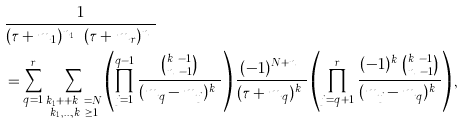<formula> <loc_0><loc_0><loc_500><loc_500>& \frac { 1 } { ( \tau + m _ { 1 } ) ^ { n _ { 1 } } \cdots ( \tau + m _ { r } ) ^ { n _ { r } } } \\ & = \sum _ { q = 1 } ^ { r } \sum _ { \substack { k _ { 1 } + \cdots + k _ { r } = N \\ k _ { 1 } , \dots , k _ { r } \geq 1 } } \left ( \prod _ { j = 1 } ^ { q - 1 } \frac { \binom { k _ { j } - 1 } { n _ { j } - 1 } } { ( m _ { q } - m _ { j } ) ^ { k _ { j } } } \right ) \frac { ( - 1 ) ^ { N + n _ { q } } } { ( \tau + m _ { q } ) ^ { k _ { q } } } \left ( \prod _ { j = q + 1 } ^ { r } \frac { ( - 1 ) ^ { k _ { j } } \binom { k _ { j } - 1 } { n _ { j } - 1 } } { ( m _ { j } - m _ { q } ) ^ { k _ { j } } } \right ) ,</formula> 